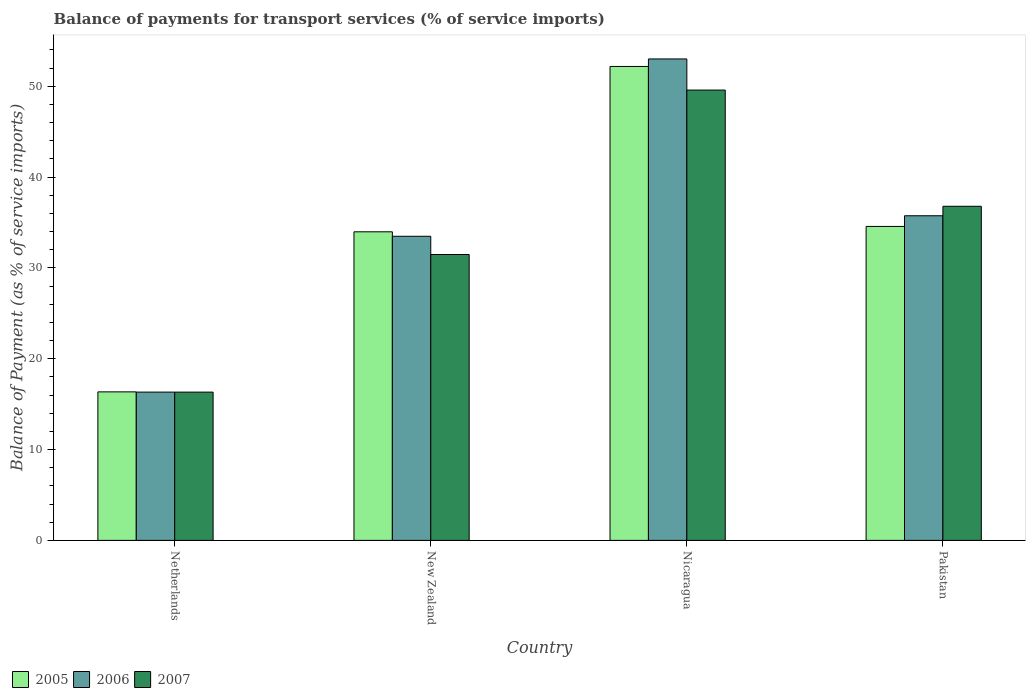How many groups of bars are there?
Ensure brevity in your answer.  4. Are the number of bars per tick equal to the number of legend labels?
Provide a short and direct response. Yes. How many bars are there on the 1st tick from the left?
Give a very brief answer. 3. What is the label of the 2nd group of bars from the left?
Offer a very short reply. New Zealand. In how many cases, is the number of bars for a given country not equal to the number of legend labels?
Offer a terse response. 0. What is the balance of payments for transport services in 2006 in Netherlands?
Provide a succinct answer. 16.33. Across all countries, what is the maximum balance of payments for transport services in 2006?
Provide a short and direct response. 53.01. Across all countries, what is the minimum balance of payments for transport services in 2006?
Provide a short and direct response. 16.33. In which country was the balance of payments for transport services in 2006 maximum?
Your answer should be very brief. Nicaragua. What is the total balance of payments for transport services in 2005 in the graph?
Offer a terse response. 137.09. What is the difference between the balance of payments for transport services in 2005 in New Zealand and that in Pakistan?
Make the answer very short. -0.59. What is the difference between the balance of payments for transport services in 2005 in Netherlands and the balance of payments for transport services in 2006 in New Zealand?
Offer a very short reply. -17.13. What is the average balance of payments for transport services in 2006 per country?
Provide a succinct answer. 34.64. What is the difference between the balance of payments for transport services of/in 2007 and balance of payments for transport services of/in 2006 in Pakistan?
Ensure brevity in your answer.  1.04. In how many countries, is the balance of payments for transport services in 2005 greater than 46 %?
Provide a succinct answer. 1. What is the ratio of the balance of payments for transport services in 2007 in Nicaragua to that in Pakistan?
Give a very brief answer. 1.35. Is the balance of payments for transport services in 2007 in New Zealand less than that in Nicaragua?
Provide a short and direct response. Yes. What is the difference between the highest and the second highest balance of payments for transport services in 2005?
Your answer should be very brief. -0.59. What is the difference between the highest and the lowest balance of payments for transport services in 2005?
Your answer should be compact. 35.83. In how many countries, is the balance of payments for transport services in 2006 greater than the average balance of payments for transport services in 2006 taken over all countries?
Your answer should be very brief. 2. Is the sum of the balance of payments for transport services in 2007 in New Zealand and Pakistan greater than the maximum balance of payments for transport services in 2005 across all countries?
Offer a very short reply. Yes. What does the 2nd bar from the right in Nicaragua represents?
Keep it short and to the point. 2006. Is it the case that in every country, the sum of the balance of payments for transport services in 2006 and balance of payments for transport services in 2007 is greater than the balance of payments for transport services in 2005?
Offer a terse response. Yes. How many bars are there?
Make the answer very short. 12. How many countries are there in the graph?
Ensure brevity in your answer.  4. What is the difference between two consecutive major ticks on the Y-axis?
Provide a short and direct response. 10. Does the graph contain any zero values?
Your answer should be compact. No. Where does the legend appear in the graph?
Provide a short and direct response. Bottom left. How are the legend labels stacked?
Your answer should be very brief. Horizontal. What is the title of the graph?
Make the answer very short. Balance of payments for transport services (% of service imports). Does "2012" appear as one of the legend labels in the graph?
Ensure brevity in your answer.  No. What is the label or title of the Y-axis?
Your answer should be compact. Balance of Payment (as % of service imports). What is the Balance of Payment (as % of service imports) of 2005 in Netherlands?
Give a very brief answer. 16.35. What is the Balance of Payment (as % of service imports) in 2006 in Netherlands?
Your response must be concise. 16.33. What is the Balance of Payment (as % of service imports) of 2007 in Netherlands?
Give a very brief answer. 16.33. What is the Balance of Payment (as % of service imports) in 2005 in New Zealand?
Offer a terse response. 33.98. What is the Balance of Payment (as % of service imports) of 2006 in New Zealand?
Make the answer very short. 33.49. What is the Balance of Payment (as % of service imports) of 2007 in New Zealand?
Your response must be concise. 31.48. What is the Balance of Payment (as % of service imports) of 2005 in Nicaragua?
Provide a succinct answer. 52.19. What is the Balance of Payment (as % of service imports) of 2006 in Nicaragua?
Ensure brevity in your answer.  53.01. What is the Balance of Payment (as % of service imports) in 2007 in Nicaragua?
Provide a short and direct response. 49.59. What is the Balance of Payment (as % of service imports) in 2005 in Pakistan?
Provide a succinct answer. 34.57. What is the Balance of Payment (as % of service imports) in 2006 in Pakistan?
Offer a very short reply. 35.75. What is the Balance of Payment (as % of service imports) in 2007 in Pakistan?
Keep it short and to the point. 36.79. Across all countries, what is the maximum Balance of Payment (as % of service imports) in 2005?
Your answer should be compact. 52.19. Across all countries, what is the maximum Balance of Payment (as % of service imports) of 2006?
Offer a very short reply. 53.01. Across all countries, what is the maximum Balance of Payment (as % of service imports) in 2007?
Offer a terse response. 49.59. Across all countries, what is the minimum Balance of Payment (as % of service imports) of 2005?
Offer a very short reply. 16.35. Across all countries, what is the minimum Balance of Payment (as % of service imports) of 2006?
Ensure brevity in your answer.  16.33. Across all countries, what is the minimum Balance of Payment (as % of service imports) of 2007?
Make the answer very short. 16.33. What is the total Balance of Payment (as % of service imports) of 2005 in the graph?
Keep it short and to the point. 137.09. What is the total Balance of Payment (as % of service imports) of 2006 in the graph?
Your response must be concise. 138.58. What is the total Balance of Payment (as % of service imports) in 2007 in the graph?
Offer a very short reply. 134.19. What is the difference between the Balance of Payment (as % of service imports) of 2005 in Netherlands and that in New Zealand?
Offer a very short reply. -17.63. What is the difference between the Balance of Payment (as % of service imports) of 2006 in Netherlands and that in New Zealand?
Offer a terse response. -17.16. What is the difference between the Balance of Payment (as % of service imports) of 2007 in Netherlands and that in New Zealand?
Your answer should be very brief. -15.15. What is the difference between the Balance of Payment (as % of service imports) in 2005 in Netherlands and that in Nicaragua?
Your response must be concise. -35.83. What is the difference between the Balance of Payment (as % of service imports) in 2006 in Netherlands and that in Nicaragua?
Make the answer very short. -36.69. What is the difference between the Balance of Payment (as % of service imports) of 2007 in Netherlands and that in Nicaragua?
Your answer should be very brief. -33.26. What is the difference between the Balance of Payment (as % of service imports) in 2005 in Netherlands and that in Pakistan?
Offer a terse response. -18.22. What is the difference between the Balance of Payment (as % of service imports) in 2006 in Netherlands and that in Pakistan?
Offer a very short reply. -19.42. What is the difference between the Balance of Payment (as % of service imports) in 2007 in Netherlands and that in Pakistan?
Make the answer very short. -20.46. What is the difference between the Balance of Payment (as % of service imports) in 2005 in New Zealand and that in Nicaragua?
Make the answer very short. -18.21. What is the difference between the Balance of Payment (as % of service imports) in 2006 in New Zealand and that in Nicaragua?
Make the answer very short. -19.53. What is the difference between the Balance of Payment (as % of service imports) in 2007 in New Zealand and that in Nicaragua?
Give a very brief answer. -18.11. What is the difference between the Balance of Payment (as % of service imports) in 2005 in New Zealand and that in Pakistan?
Keep it short and to the point. -0.59. What is the difference between the Balance of Payment (as % of service imports) of 2006 in New Zealand and that in Pakistan?
Your answer should be compact. -2.26. What is the difference between the Balance of Payment (as % of service imports) of 2007 in New Zealand and that in Pakistan?
Your answer should be very brief. -5.31. What is the difference between the Balance of Payment (as % of service imports) in 2005 in Nicaragua and that in Pakistan?
Offer a terse response. 17.61. What is the difference between the Balance of Payment (as % of service imports) in 2006 in Nicaragua and that in Pakistan?
Your answer should be very brief. 17.27. What is the difference between the Balance of Payment (as % of service imports) in 2007 in Nicaragua and that in Pakistan?
Provide a short and direct response. 12.8. What is the difference between the Balance of Payment (as % of service imports) in 2005 in Netherlands and the Balance of Payment (as % of service imports) in 2006 in New Zealand?
Provide a succinct answer. -17.13. What is the difference between the Balance of Payment (as % of service imports) of 2005 in Netherlands and the Balance of Payment (as % of service imports) of 2007 in New Zealand?
Offer a terse response. -15.13. What is the difference between the Balance of Payment (as % of service imports) in 2006 in Netherlands and the Balance of Payment (as % of service imports) in 2007 in New Zealand?
Offer a very short reply. -15.15. What is the difference between the Balance of Payment (as % of service imports) in 2005 in Netherlands and the Balance of Payment (as % of service imports) in 2006 in Nicaragua?
Provide a succinct answer. -36.66. What is the difference between the Balance of Payment (as % of service imports) in 2005 in Netherlands and the Balance of Payment (as % of service imports) in 2007 in Nicaragua?
Ensure brevity in your answer.  -33.23. What is the difference between the Balance of Payment (as % of service imports) in 2006 in Netherlands and the Balance of Payment (as % of service imports) in 2007 in Nicaragua?
Your answer should be compact. -33.26. What is the difference between the Balance of Payment (as % of service imports) in 2005 in Netherlands and the Balance of Payment (as % of service imports) in 2006 in Pakistan?
Your answer should be compact. -19.39. What is the difference between the Balance of Payment (as % of service imports) in 2005 in Netherlands and the Balance of Payment (as % of service imports) in 2007 in Pakistan?
Provide a succinct answer. -20.44. What is the difference between the Balance of Payment (as % of service imports) of 2006 in Netherlands and the Balance of Payment (as % of service imports) of 2007 in Pakistan?
Keep it short and to the point. -20.46. What is the difference between the Balance of Payment (as % of service imports) of 2005 in New Zealand and the Balance of Payment (as % of service imports) of 2006 in Nicaragua?
Your answer should be very brief. -19.03. What is the difference between the Balance of Payment (as % of service imports) in 2005 in New Zealand and the Balance of Payment (as % of service imports) in 2007 in Nicaragua?
Make the answer very short. -15.61. What is the difference between the Balance of Payment (as % of service imports) of 2006 in New Zealand and the Balance of Payment (as % of service imports) of 2007 in Nicaragua?
Provide a short and direct response. -16.1. What is the difference between the Balance of Payment (as % of service imports) of 2005 in New Zealand and the Balance of Payment (as % of service imports) of 2006 in Pakistan?
Your answer should be very brief. -1.77. What is the difference between the Balance of Payment (as % of service imports) of 2005 in New Zealand and the Balance of Payment (as % of service imports) of 2007 in Pakistan?
Your answer should be compact. -2.81. What is the difference between the Balance of Payment (as % of service imports) of 2006 in New Zealand and the Balance of Payment (as % of service imports) of 2007 in Pakistan?
Provide a short and direct response. -3.3. What is the difference between the Balance of Payment (as % of service imports) in 2005 in Nicaragua and the Balance of Payment (as % of service imports) in 2006 in Pakistan?
Keep it short and to the point. 16.44. What is the difference between the Balance of Payment (as % of service imports) in 2005 in Nicaragua and the Balance of Payment (as % of service imports) in 2007 in Pakistan?
Provide a succinct answer. 15.39. What is the difference between the Balance of Payment (as % of service imports) of 2006 in Nicaragua and the Balance of Payment (as % of service imports) of 2007 in Pakistan?
Give a very brief answer. 16.22. What is the average Balance of Payment (as % of service imports) in 2005 per country?
Make the answer very short. 34.27. What is the average Balance of Payment (as % of service imports) in 2006 per country?
Make the answer very short. 34.64. What is the average Balance of Payment (as % of service imports) of 2007 per country?
Offer a terse response. 33.55. What is the difference between the Balance of Payment (as % of service imports) in 2005 and Balance of Payment (as % of service imports) in 2006 in Netherlands?
Offer a very short reply. 0.03. What is the difference between the Balance of Payment (as % of service imports) of 2005 and Balance of Payment (as % of service imports) of 2007 in Netherlands?
Keep it short and to the point. 0.03. What is the difference between the Balance of Payment (as % of service imports) of 2006 and Balance of Payment (as % of service imports) of 2007 in Netherlands?
Offer a very short reply. 0. What is the difference between the Balance of Payment (as % of service imports) in 2005 and Balance of Payment (as % of service imports) in 2006 in New Zealand?
Give a very brief answer. 0.49. What is the difference between the Balance of Payment (as % of service imports) of 2005 and Balance of Payment (as % of service imports) of 2007 in New Zealand?
Ensure brevity in your answer.  2.5. What is the difference between the Balance of Payment (as % of service imports) in 2006 and Balance of Payment (as % of service imports) in 2007 in New Zealand?
Your answer should be very brief. 2.01. What is the difference between the Balance of Payment (as % of service imports) of 2005 and Balance of Payment (as % of service imports) of 2006 in Nicaragua?
Make the answer very short. -0.83. What is the difference between the Balance of Payment (as % of service imports) of 2005 and Balance of Payment (as % of service imports) of 2007 in Nicaragua?
Provide a succinct answer. 2.6. What is the difference between the Balance of Payment (as % of service imports) in 2006 and Balance of Payment (as % of service imports) in 2007 in Nicaragua?
Your response must be concise. 3.43. What is the difference between the Balance of Payment (as % of service imports) in 2005 and Balance of Payment (as % of service imports) in 2006 in Pakistan?
Make the answer very short. -1.17. What is the difference between the Balance of Payment (as % of service imports) of 2005 and Balance of Payment (as % of service imports) of 2007 in Pakistan?
Make the answer very short. -2.22. What is the difference between the Balance of Payment (as % of service imports) of 2006 and Balance of Payment (as % of service imports) of 2007 in Pakistan?
Ensure brevity in your answer.  -1.04. What is the ratio of the Balance of Payment (as % of service imports) of 2005 in Netherlands to that in New Zealand?
Give a very brief answer. 0.48. What is the ratio of the Balance of Payment (as % of service imports) in 2006 in Netherlands to that in New Zealand?
Give a very brief answer. 0.49. What is the ratio of the Balance of Payment (as % of service imports) of 2007 in Netherlands to that in New Zealand?
Offer a terse response. 0.52. What is the ratio of the Balance of Payment (as % of service imports) of 2005 in Netherlands to that in Nicaragua?
Your answer should be very brief. 0.31. What is the ratio of the Balance of Payment (as % of service imports) of 2006 in Netherlands to that in Nicaragua?
Ensure brevity in your answer.  0.31. What is the ratio of the Balance of Payment (as % of service imports) in 2007 in Netherlands to that in Nicaragua?
Offer a terse response. 0.33. What is the ratio of the Balance of Payment (as % of service imports) in 2005 in Netherlands to that in Pakistan?
Offer a very short reply. 0.47. What is the ratio of the Balance of Payment (as % of service imports) in 2006 in Netherlands to that in Pakistan?
Provide a succinct answer. 0.46. What is the ratio of the Balance of Payment (as % of service imports) in 2007 in Netherlands to that in Pakistan?
Provide a short and direct response. 0.44. What is the ratio of the Balance of Payment (as % of service imports) of 2005 in New Zealand to that in Nicaragua?
Offer a very short reply. 0.65. What is the ratio of the Balance of Payment (as % of service imports) in 2006 in New Zealand to that in Nicaragua?
Your answer should be very brief. 0.63. What is the ratio of the Balance of Payment (as % of service imports) in 2007 in New Zealand to that in Nicaragua?
Keep it short and to the point. 0.63. What is the ratio of the Balance of Payment (as % of service imports) in 2005 in New Zealand to that in Pakistan?
Keep it short and to the point. 0.98. What is the ratio of the Balance of Payment (as % of service imports) of 2006 in New Zealand to that in Pakistan?
Make the answer very short. 0.94. What is the ratio of the Balance of Payment (as % of service imports) of 2007 in New Zealand to that in Pakistan?
Offer a very short reply. 0.86. What is the ratio of the Balance of Payment (as % of service imports) of 2005 in Nicaragua to that in Pakistan?
Your answer should be compact. 1.51. What is the ratio of the Balance of Payment (as % of service imports) in 2006 in Nicaragua to that in Pakistan?
Your response must be concise. 1.48. What is the ratio of the Balance of Payment (as % of service imports) of 2007 in Nicaragua to that in Pakistan?
Give a very brief answer. 1.35. What is the difference between the highest and the second highest Balance of Payment (as % of service imports) of 2005?
Your answer should be very brief. 17.61. What is the difference between the highest and the second highest Balance of Payment (as % of service imports) in 2006?
Provide a short and direct response. 17.27. What is the difference between the highest and the second highest Balance of Payment (as % of service imports) in 2007?
Ensure brevity in your answer.  12.8. What is the difference between the highest and the lowest Balance of Payment (as % of service imports) of 2005?
Offer a terse response. 35.83. What is the difference between the highest and the lowest Balance of Payment (as % of service imports) of 2006?
Offer a terse response. 36.69. What is the difference between the highest and the lowest Balance of Payment (as % of service imports) of 2007?
Offer a terse response. 33.26. 